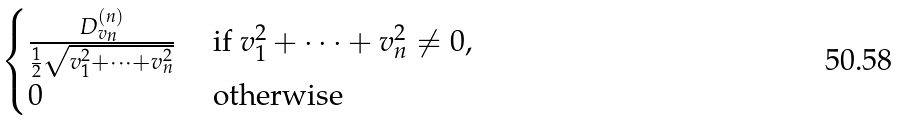Convert formula to latex. <formula><loc_0><loc_0><loc_500><loc_500>\begin{cases} \frac { D ^ { ( n ) } _ { v _ { n } } } { \frac { 1 } { 2 } \sqrt { v _ { 1 } ^ { 2 } + \dots + v _ { n } ^ { 2 } } } & \text { if } v _ { 1 } ^ { 2 } + \dots + v _ { n } ^ { 2 } \ne 0 , \\ 0 & \text { otherwise } \\ \end{cases}</formula> 